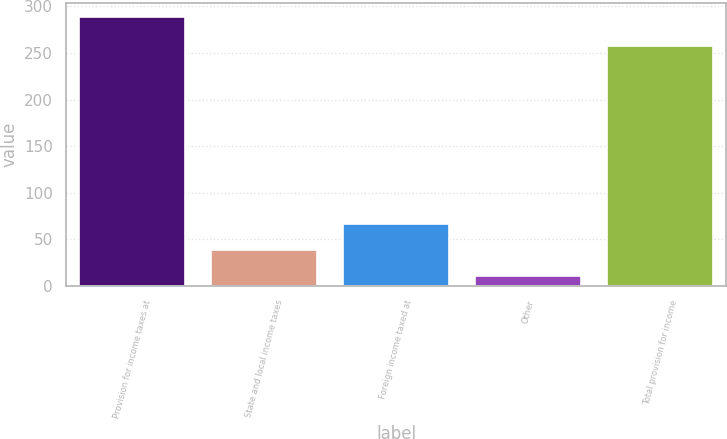Convert chart. <chart><loc_0><loc_0><loc_500><loc_500><bar_chart><fcel>Provision for income taxes at<fcel>State and local income taxes<fcel>Foreign income taxed at<fcel>Other<fcel>Total provision for income<nl><fcel>288.9<fcel>38.07<fcel>65.94<fcel>10.2<fcel>257.8<nl></chart> 